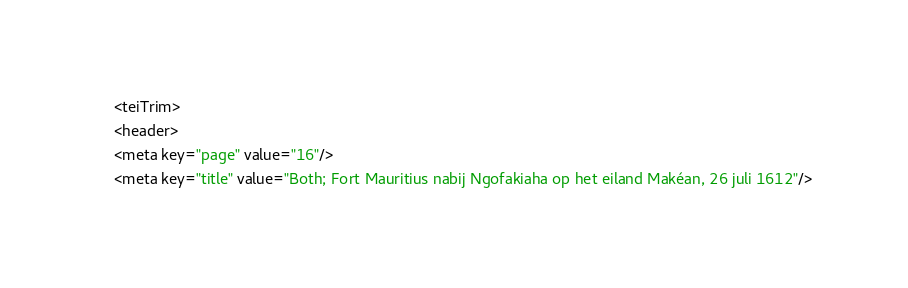<code> <loc_0><loc_0><loc_500><loc_500><_XML_><teiTrim>
<header>
<meta key="page" value="16"/>
<meta key="title" value="Both; Fort Mauritius nabij Ngofakiaha op het eiland Makéan, 26 juli 1612"/></code> 